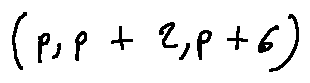Convert formula to latex. <formula><loc_0><loc_0><loc_500><loc_500>( p , p + 2 , p + 6 )</formula> 